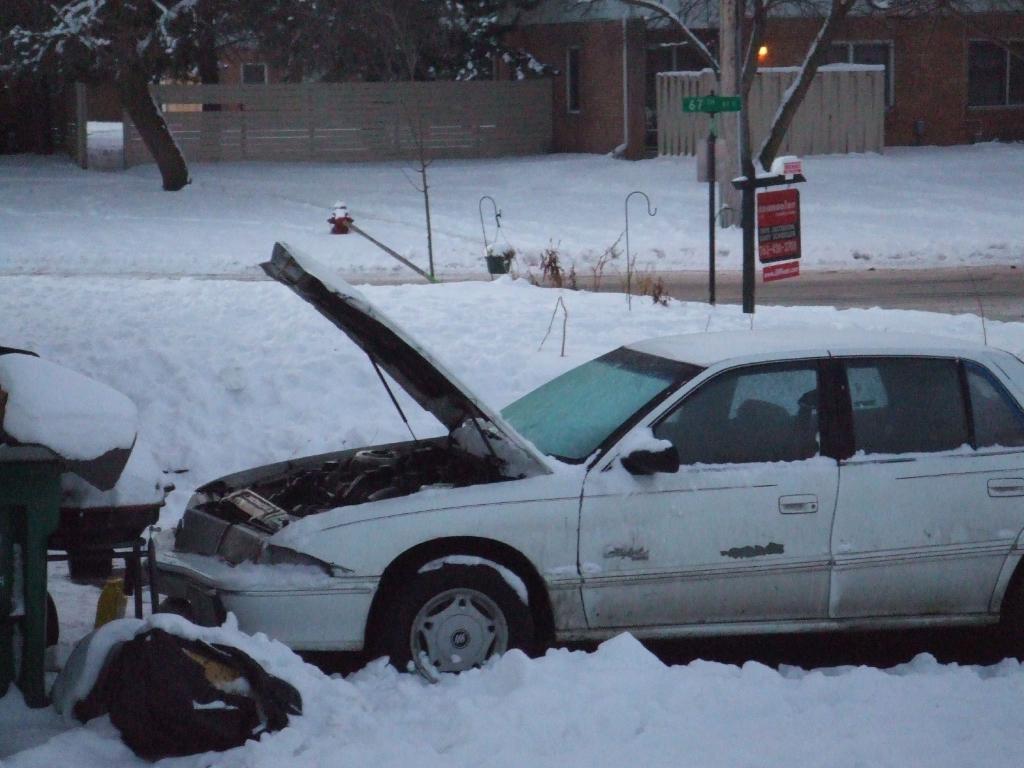Can you describe this image briefly? In the foreground of the image we can see a car. To the left side of the image we can see the table in the snow. In the background, we can see a building with windows, fence, a group of trees, poles, basket on a hook. 